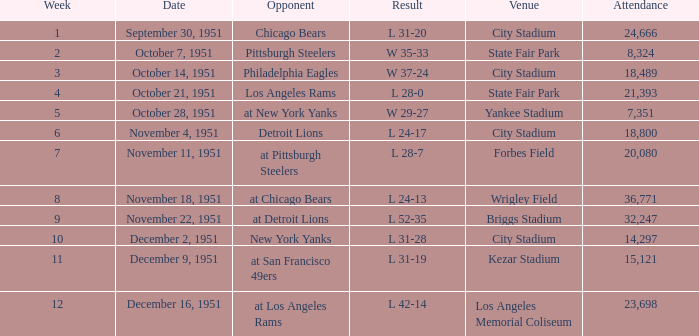Which venue hosted the Los Angeles Rams as an opponent? State Fair Park. Help me parse the entirety of this table. {'header': ['Week', 'Date', 'Opponent', 'Result', 'Venue', 'Attendance'], 'rows': [['1', 'September 30, 1951', 'Chicago Bears', 'L 31-20', 'City Stadium', '24,666'], ['2', 'October 7, 1951', 'Pittsburgh Steelers', 'W 35-33', 'State Fair Park', '8,324'], ['3', 'October 14, 1951', 'Philadelphia Eagles', 'W 37-24', 'City Stadium', '18,489'], ['4', 'October 21, 1951', 'Los Angeles Rams', 'L 28-0', 'State Fair Park', '21,393'], ['5', 'October 28, 1951', 'at New York Yanks', 'W 29-27', 'Yankee Stadium', '7,351'], ['6', 'November 4, 1951', 'Detroit Lions', 'L 24-17', 'City Stadium', '18,800'], ['7', 'November 11, 1951', 'at Pittsburgh Steelers', 'L 28-7', 'Forbes Field', '20,080'], ['8', 'November 18, 1951', 'at Chicago Bears', 'L 24-13', 'Wrigley Field', '36,771'], ['9', 'November 22, 1951', 'at Detroit Lions', 'L 52-35', 'Briggs Stadium', '32,247'], ['10', 'December 2, 1951', 'New York Yanks', 'L 31-28', 'City Stadium', '14,297'], ['11', 'December 9, 1951', 'at San Francisco 49ers', 'L 31-19', 'Kezar Stadium', '15,121'], ['12', 'December 16, 1951', 'at Los Angeles Rams', 'L 42-14', 'Los Angeles Memorial Coliseum', '23,698']]} 